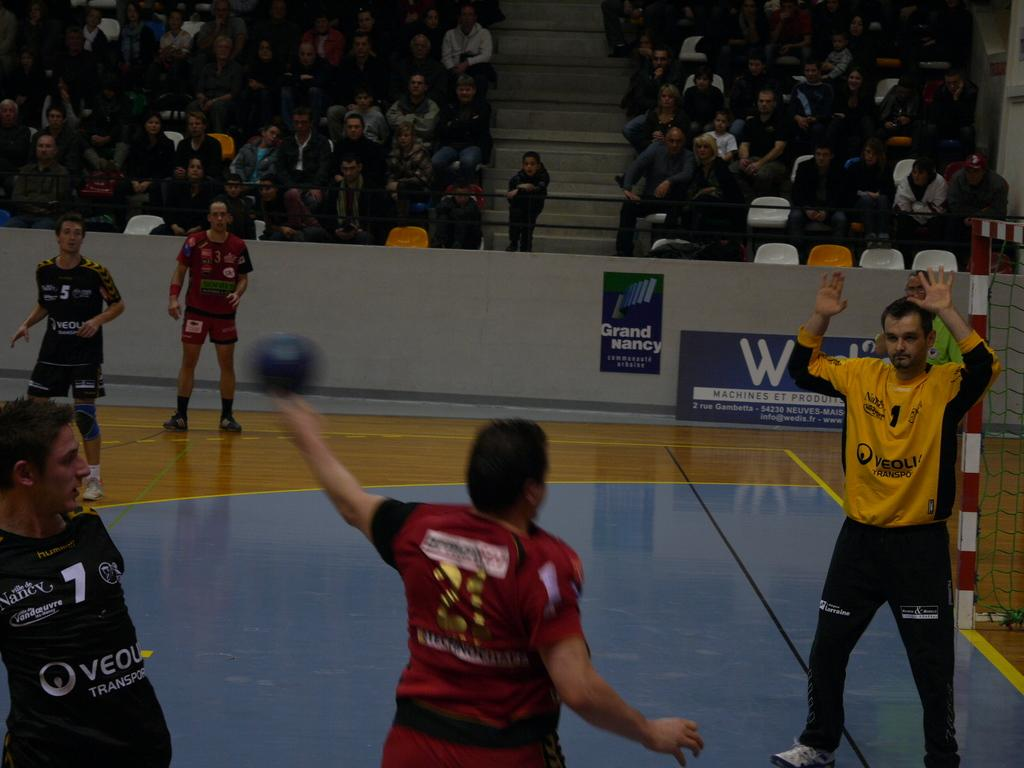<image>
Write a terse but informative summary of the picture. people in an indoor gym in front of a sign for Grand Nancy 